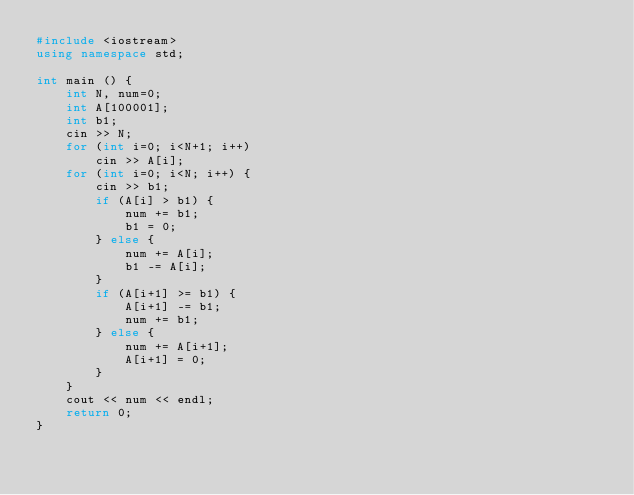<code> <loc_0><loc_0><loc_500><loc_500><_C++_>#include <iostream>
using namespace std;

int main () {
	int N, num=0;
	int A[100001];
	int b1;
	cin >> N;
	for (int i=0; i<N+1; i++)
		cin >> A[i];
	for (int i=0; i<N; i++) {
		cin >> b1;
		if (A[i] > b1) {
			num += b1;
			b1 = 0;
		} else {
			num += A[i];
			b1 -= A[i];
		}
		if (A[i+1] >= b1) {
			A[i+1] -= b1;
			num += b1;
		} else {
			num += A[i+1];
			A[i+1] = 0;
		}
	}
	cout << num << endl;
	return 0;
}</code> 